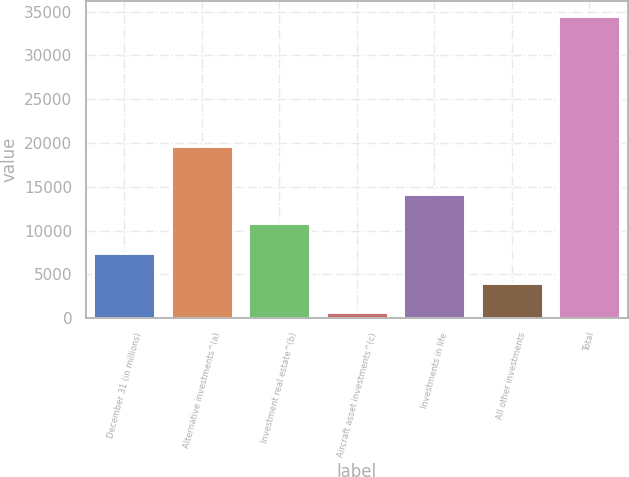Convert chart. <chart><loc_0><loc_0><loc_500><loc_500><bar_chart><fcel>December 31 (in millions)<fcel>Alternative investments^(a)<fcel>Investment real estate^(b)<fcel>Aircraft asset investments^(c)<fcel>Investments in life<fcel>All other investments<fcel>Total<nl><fcel>7424.4<fcel>19656<fcel>10811.1<fcel>651<fcel>14197.8<fcel>4037.7<fcel>34518<nl></chart> 